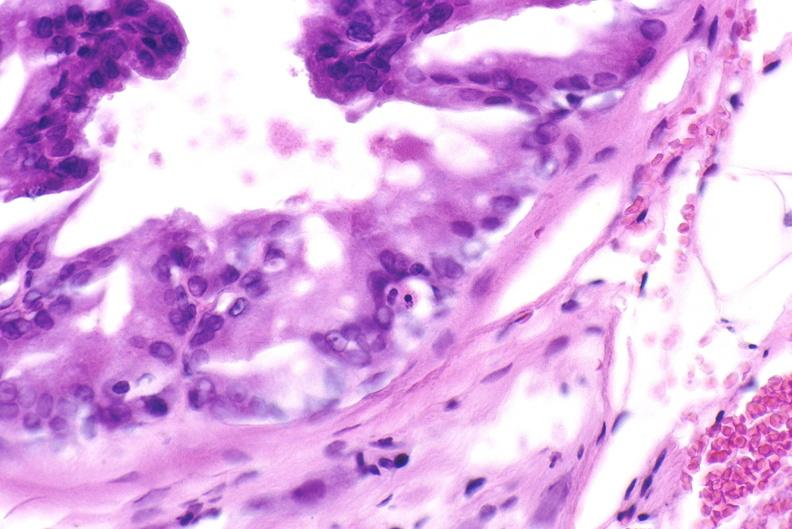what does this image show?
Answer the question using a single word or phrase. Apoptosis in prostate after orchiectomy 